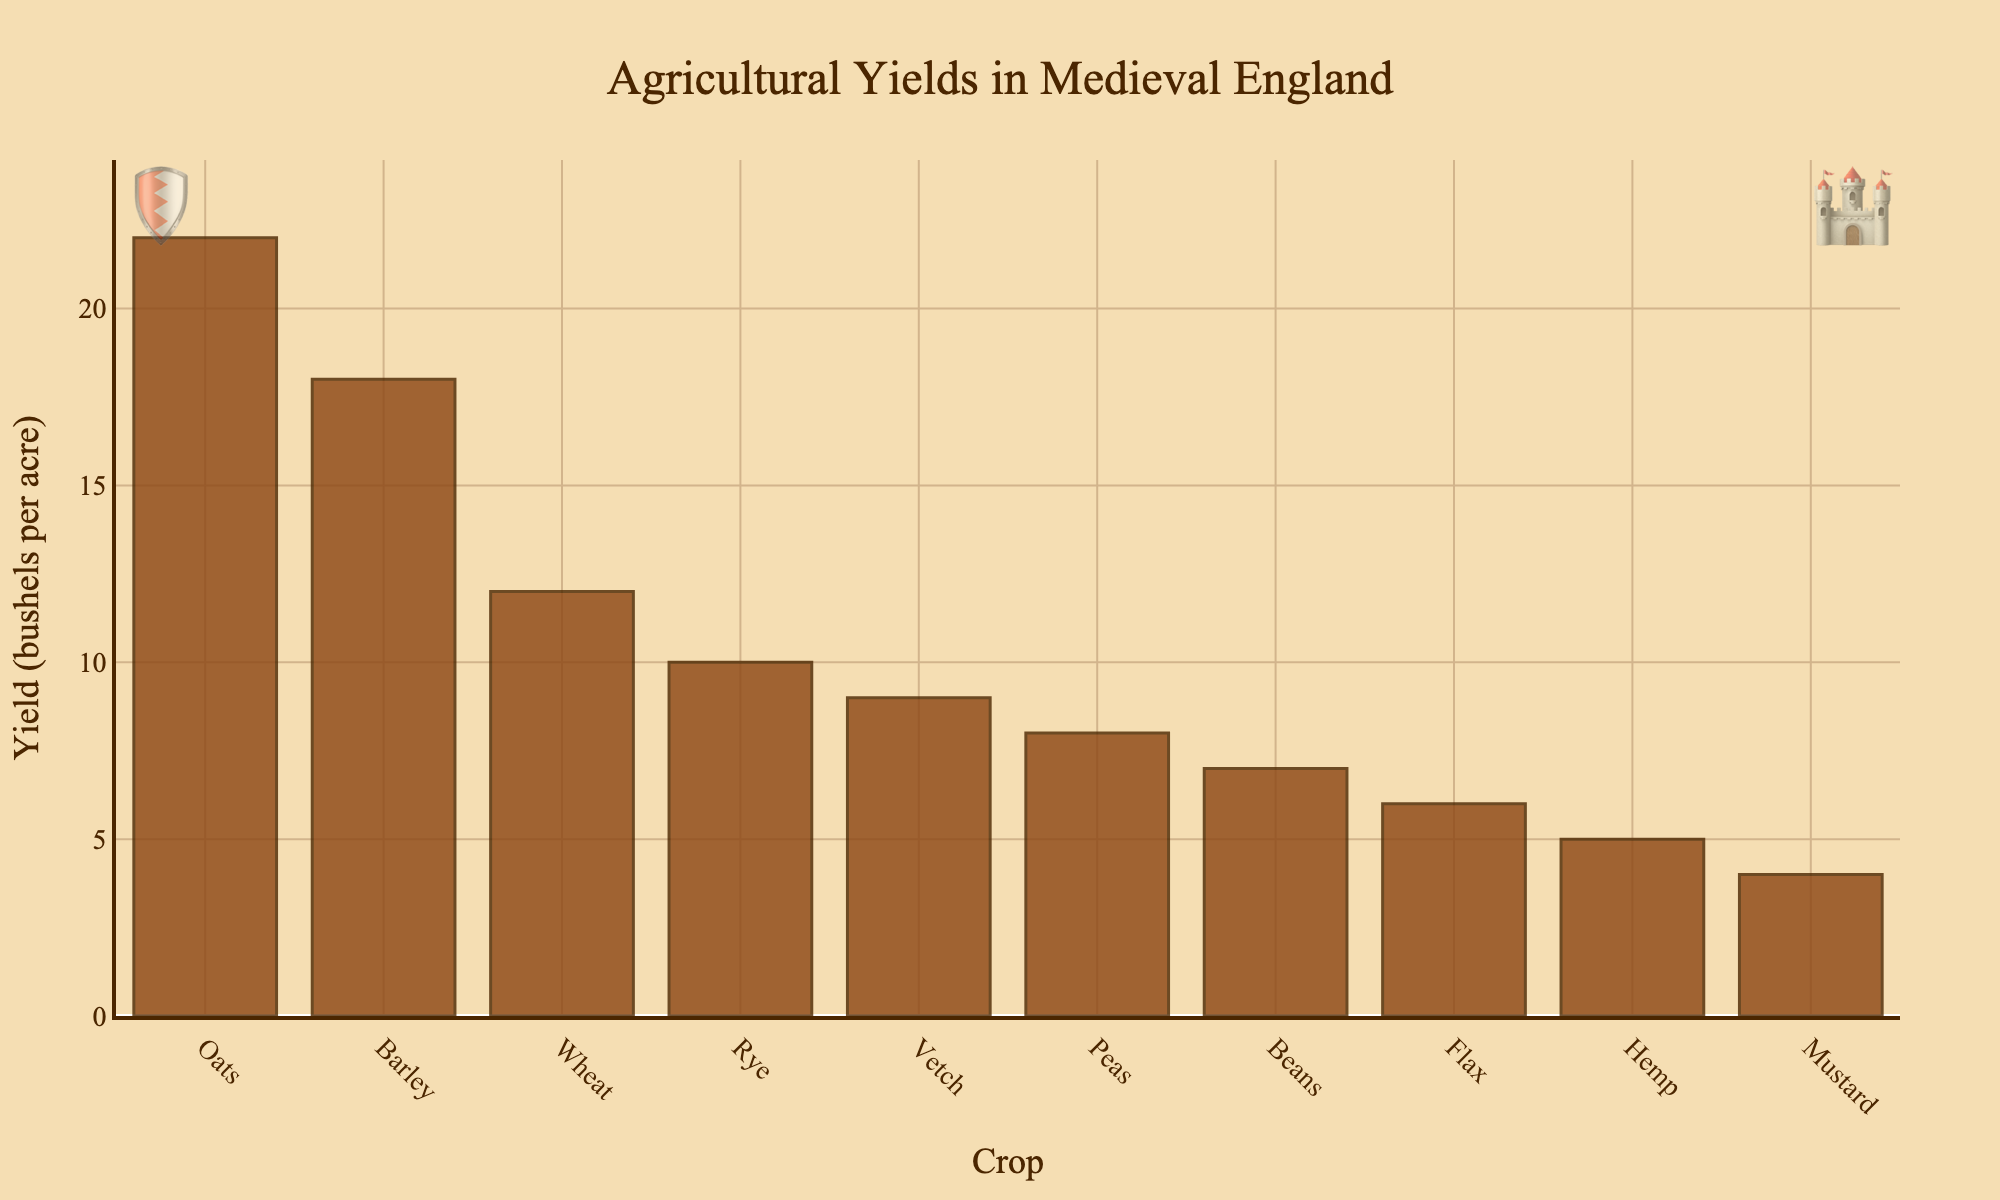What crop has the highest yield? The crop with the highest bar in the bar chart indicates the crop with the highest yield.
Answer: Oats Which crop has the lowest yield? The crop with the shortest bar in the bar chart indicates the crop with the lowest yield.
Answer: Mustard How much higher is the yield of barley compared to peas? First, find the yields of barley and peas from the bar chart, then subtract the yield of peas from the yield of barley: 18 - 8 = 10.
Answer: 10 Which crops have yields greater than 10 bushels per acre? Identify the bars that are over 10 bushels per acre by looking at the bar heights: Wheat, Barley, Oats, and Rye.
Answer: Wheat, Barley, Oats, Rye What is the combined yield of beans, flax, and hemp? Find the yields of beans, flax, and hemp from the bar chart, then add them together: 7 + 6 + 5 = 18.
Answer: 18 How does the yield of peas compare to vetch? Find the yields of peas and vetch from the bar chart and compare them: 8 (peas) and 9 (vetch). Vetch has a higher yield by 1 bushel per acre.
Answer: Vetch is higher by 1 If the total yield from all crops was evenly distributed, what would be the average yield per crop? Sum the yields of all crops and divide by the number of crops: (12 + 18 + 22 + 10 + 8 + 7 + 6 + 5 + 4 + 9) / 10 = 101 / 10 = 10.1 bushels per acre.
Answer: 10.1 What is the median yield value? Arrange the yields in ascending order: 4, 5, 6, 7, 8, 9, 10, 12, 18, 22. The median is the average of the 5th and 6th values: (8 + 9) / 2 = 8.5.
Answer: 8.5 Which crop has a higher yield, wheat or rye, and by how much? Find the yields of wheat and rye from the bar chart, then subtract the yield of rye from the yield of wheat: 12 - 10 = 2.
Answer: Wheat by 2 What is the percentage difference in yield between the highest-yielding crop and the lowest-yielding crop? Find the highest yield (22 bushels per acre for oats) and the lowest yield (4 bushels per acre for mustard). Calculate the percentage difference: ((22 - 4) / 4) * 100 = 450%.
Answer: 450% 